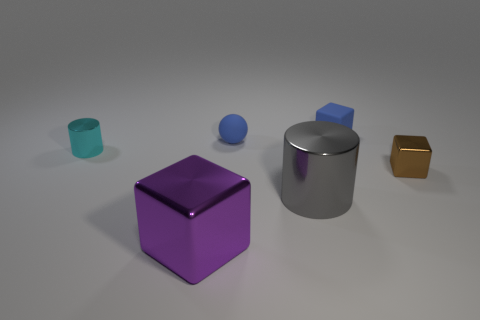Is the number of big gray metallic things that are in front of the purple metal cube less than the number of small balls that are to the right of the small ball?
Offer a very short reply. No. What shape is the blue rubber thing in front of the matte object on the right side of the small rubber ball?
Offer a terse response. Sphere. What number of other things are made of the same material as the big block?
Offer a very short reply. 3. Is there any other thing that has the same size as the cyan object?
Provide a succinct answer. Yes. Are there more gray cylinders than cylinders?
Your response must be concise. No. What size is the metal block that is to the left of the small blue thing right of the cylinder that is in front of the tiny cylinder?
Offer a terse response. Large. There is a cyan cylinder; is it the same size as the metal cube to the right of the big purple shiny block?
Offer a very short reply. Yes. Is the number of blue rubber objects that are on the right side of the small brown shiny object less than the number of small rubber cubes?
Make the answer very short. Yes. What number of small blocks are the same color as the matte ball?
Offer a very short reply. 1. Are there fewer large cylinders than blocks?
Provide a succinct answer. Yes. 